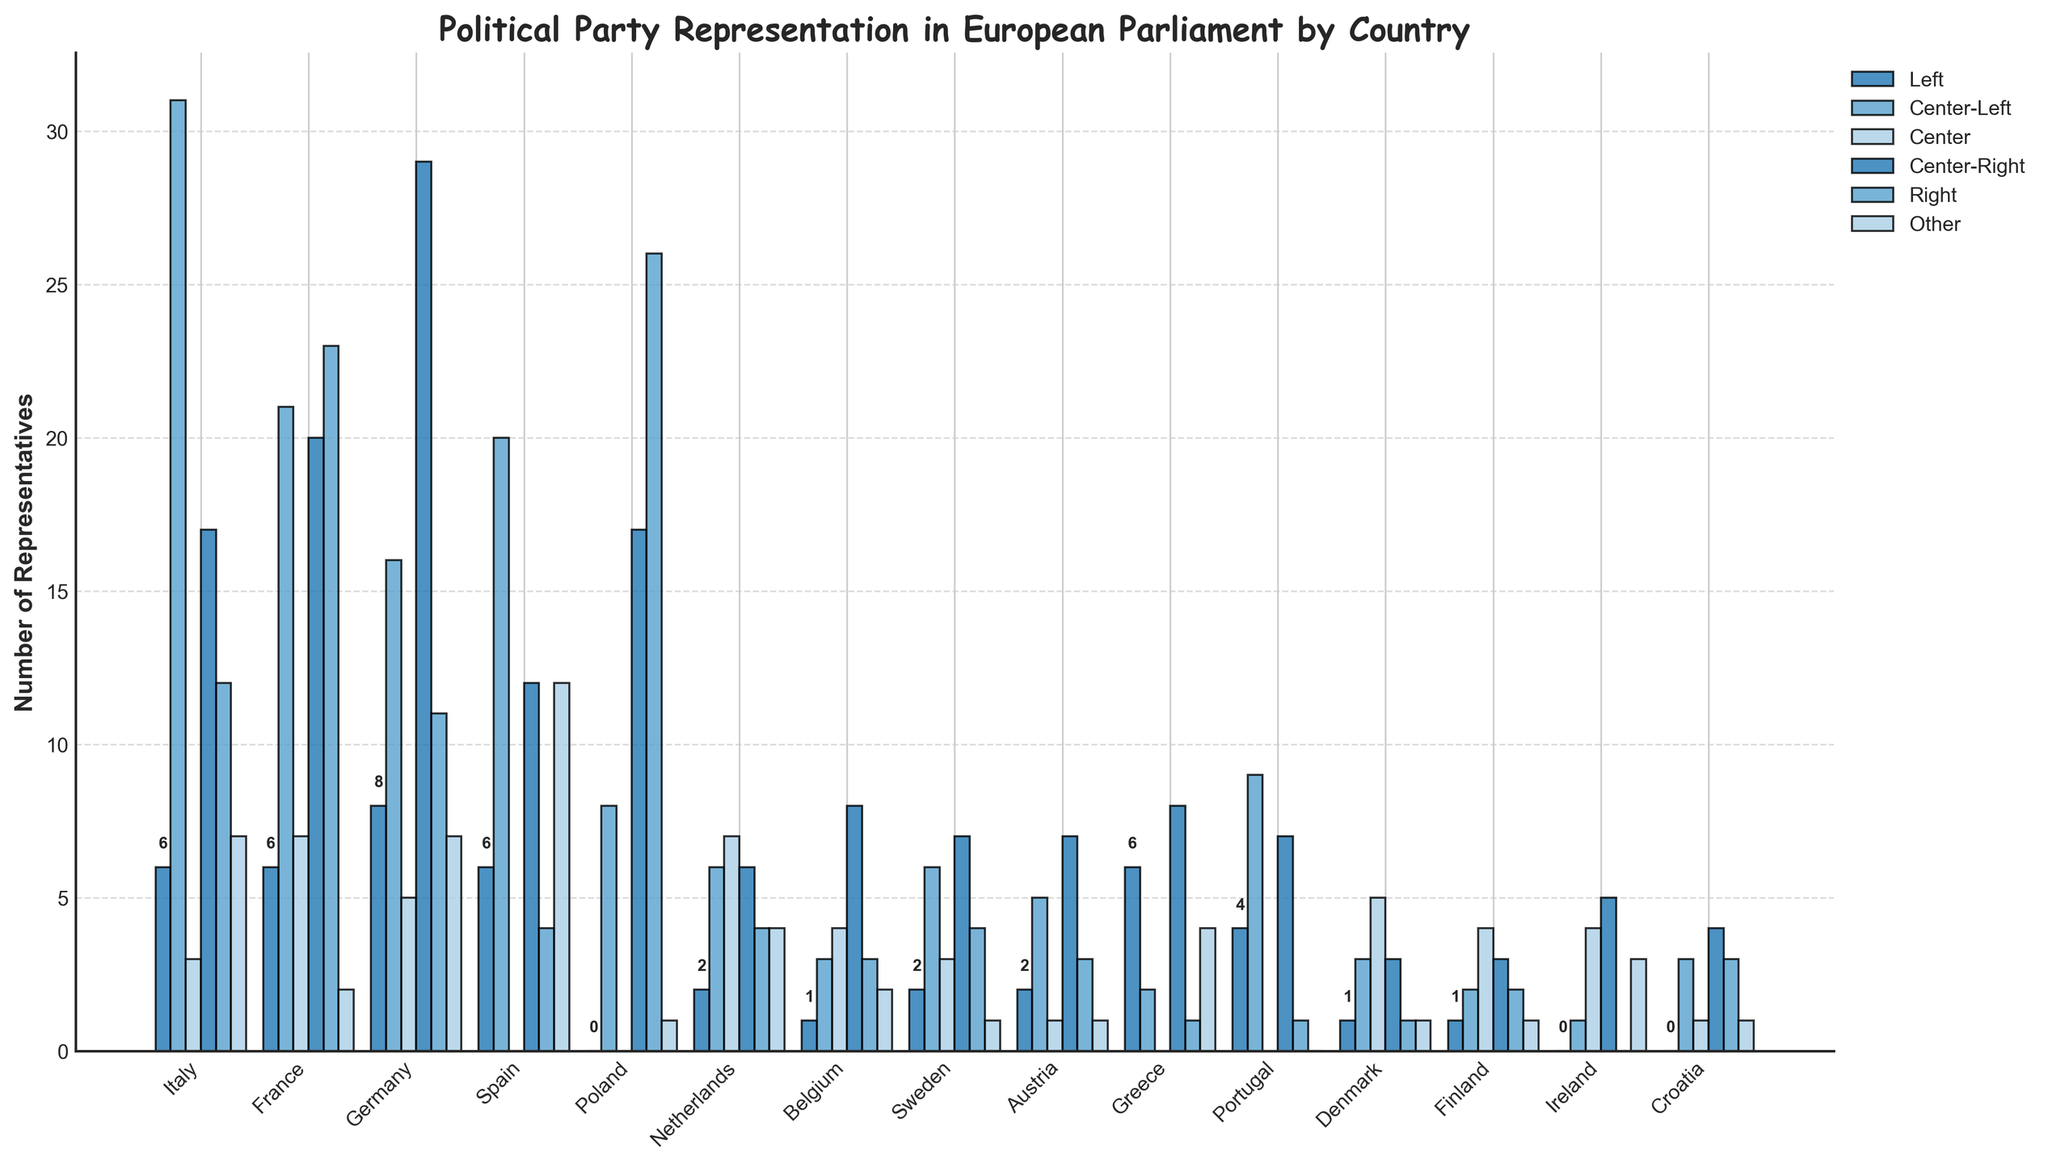Which country has the highest number of Center-Right representatives? Scan the bars representing Center-Right for each country and identify the tallest one. Poland has the highest number of Center-Right representatives with 17.
Answer: Poland What is the total number of Right representatives in France and Germany combined? Add the values of the Right representatives in France (23) and Germany (11).
Answer: 34 How many more Center-Left representatives does Italy have compared to Spain? Subtract the number of Center-Left representatives in Spain (20) from the number in Italy (31).
Answer: 11 Which party has the most representatives in Portugal? Identify the tallest bar among the different parties in Portugal. Center-Left has the most representatives with 9.
Answer: Center-Left How many countries have zero representatives in the Center party? Count the countries that have a height of zero for the Center party, which includes Spain, Poland, Greece, and Portugal. There are 4 such countries.
Answer: 4 Which country has the smallest overall number of representatives, and what is the total count for that country? Examine the sum of all party representatives for each country. Denmark has the smallest total with (1 + 3 + 5 + 3 + 1 + 1) = 14.
Answer: Denmark, 14 Which political party has the most representatives across all countries? Sum the representatives of each party across all countries and compare. Center-Right has the most representatives overall.
Answer: Center-Right What is the difference in the number of Left representatives between Germany and Italy? Subtract the number of Left representatives in Italy (6) from the number in Germany (8).
Answer: 2 Which country has an equal number of Center and Right representatives? Review the data for each country to find where the Center and Right bars have the same height. France has 7 representatives in both Center and Right.
Answer: France What is the combined number of Other representatives in Sweden and Netherlands? Add the number of Other representatives in Sweden (1) and Netherlands (4).
Answer: 5 